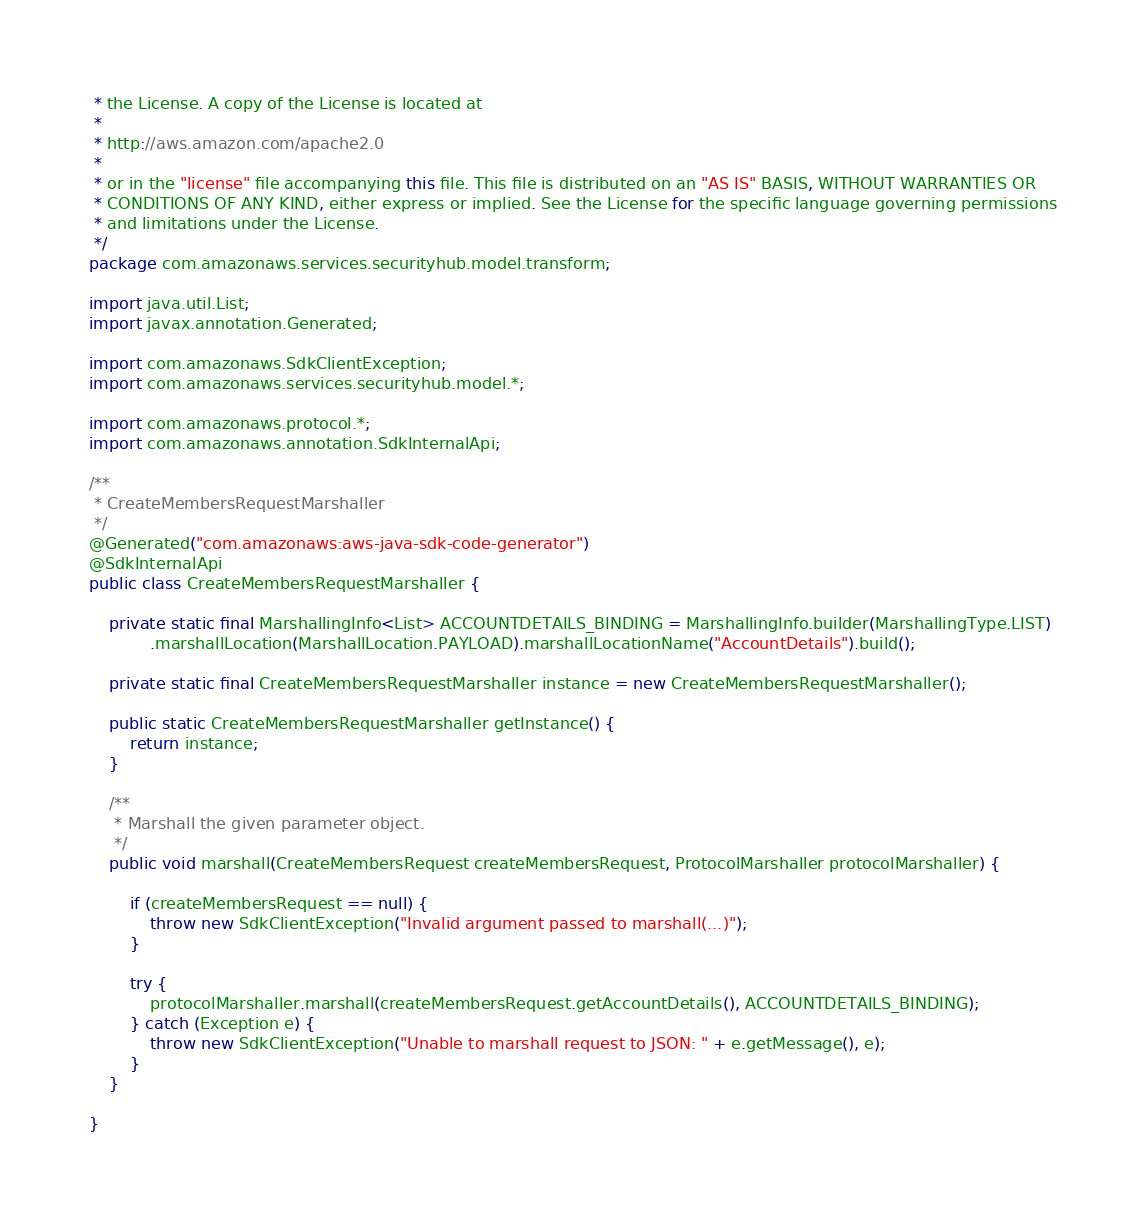<code> <loc_0><loc_0><loc_500><loc_500><_Java_> * the License. A copy of the License is located at
 * 
 * http://aws.amazon.com/apache2.0
 * 
 * or in the "license" file accompanying this file. This file is distributed on an "AS IS" BASIS, WITHOUT WARRANTIES OR
 * CONDITIONS OF ANY KIND, either express or implied. See the License for the specific language governing permissions
 * and limitations under the License.
 */
package com.amazonaws.services.securityhub.model.transform;

import java.util.List;
import javax.annotation.Generated;

import com.amazonaws.SdkClientException;
import com.amazonaws.services.securityhub.model.*;

import com.amazonaws.protocol.*;
import com.amazonaws.annotation.SdkInternalApi;

/**
 * CreateMembersRequestMarshaller
 */
@Generated("com.amazonaws:aws-java-sdk-code-generator")
@SdkInternalApi
public class CreateMembersRequestMarshaller {

    private static final MarshallingInfo<List> ACCOUNTDETAILS_BINDING = MarshallingInfo.builder(MarshallingType.LIST)
            .marshallLocation(MarshallLocation.PAYLOAD).marshallLocationName("AccountDetails").build();

    private static final CreateMembersRequestMarshaller instance = new CreateMembersRequestMarshaller();

    public static CreateMembersRequestMarshaller getInstance() {
        return instance;
    }

    /**
     * Marshall the given parameter object.
     */
    public void marshall(CreateMembersRequest createMembersRequest, ProtocolMarshaller protocolMarshaller) {

        if (createMembersRequest == null) {
            throw new SdkClientException("Invalid argument passed to marshall(...)");
        }

        try {
            protocolMarshaller.marshall(createMembersRequest.getAccountDetails(), ACCOUNTDETAILS_BINDING);
        } catch (Exception e) {
            throw new SdkClientException("Unable to marshall request to JSON: " + e.getMessage(), e);
        }
    }

}
</code> 